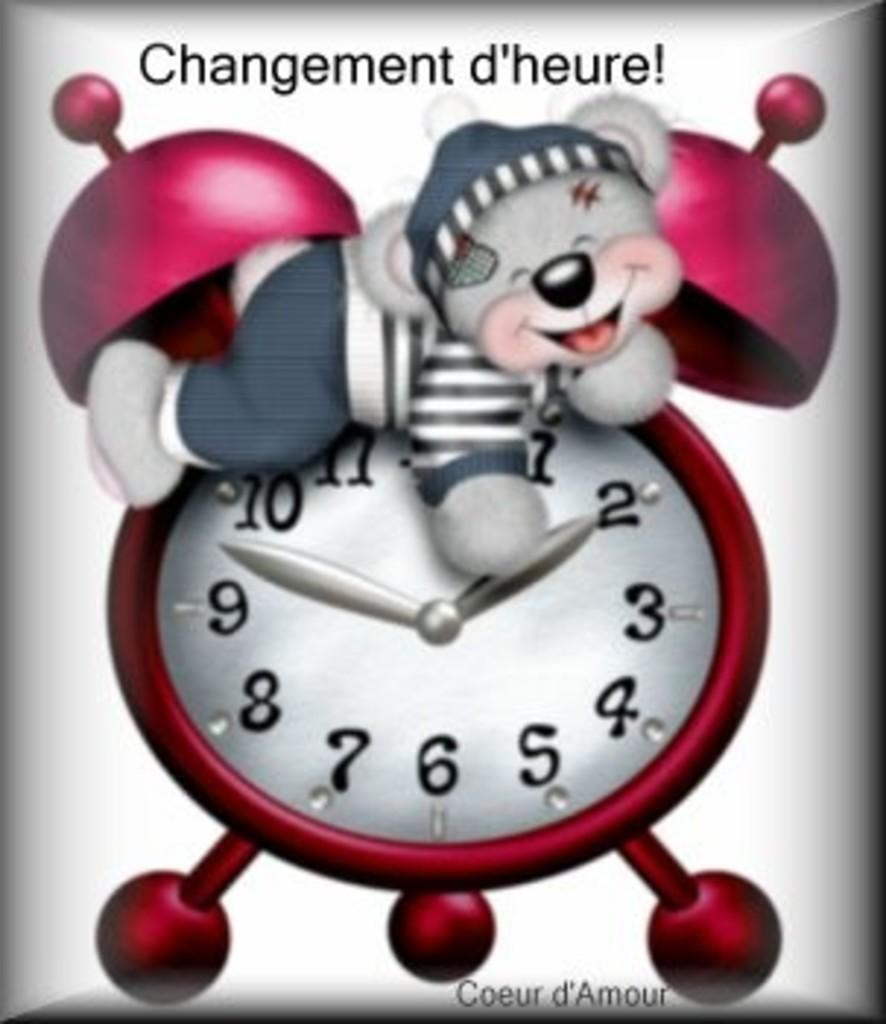Provide a one-sentence caption for the provided image. A cartoon  alarm clock picture with a teddy bear on top and a quote, Changement d'heure!ar. 